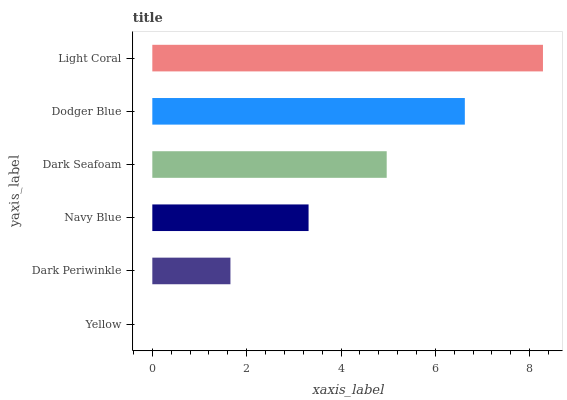Is Yellow the minimum?
Answer yes or no. Yes. Is Light Coral the maximum?
Answer yes or no. Yes. Is Dark Periwinkle the minimum?
Answer yes or no. No. Is Dark Periwinkle the maximum?
Answer yes or no. No. Is Dark Periwinkle greater than Yellow?
Answer yes or no. Yes. Is Yellow less than Dark Periwinkle?
Answer yes or no. Yes. Is Yellow greater than Dark Periwinkle?
Answer yes or no. No. Is Dark Periwinkle less than Yellow?
Answer yes or no. No. Is Dark Seafoam the high median?
Answer yes or no. Yes. Is Navy Blue the low median?
Answer yes or no. Yes. Is Dodger Blue the high median?
Answer yes or no. No. Is Dark Seafoam the low median?
Answer yes or no. No. 